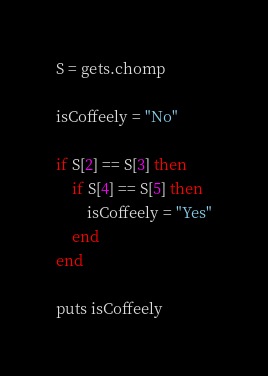<code> <loc_0><loc_0><loc_500><loc_500><_Ruby_>S = gets.chomp

isCoffeely = "No"

if S[2] == S[3] then
    if S[4] == S[5] then
        isCoffeely = "Yes"
    end
end

puts isCoffeely
</code> 